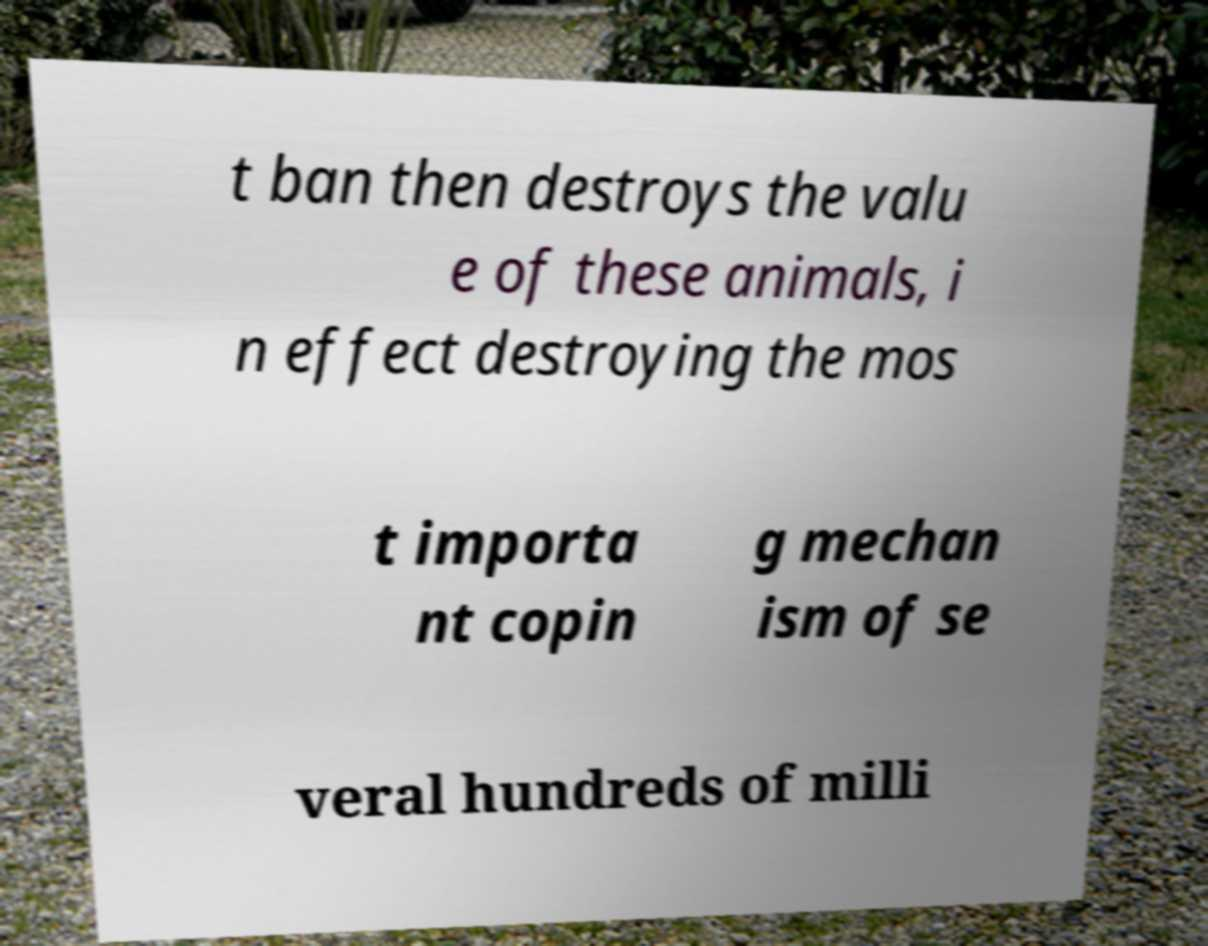I need the written content from this picture converted into text. Can you do that? t ban then destroys the valu e of these animals, i n effect destroying the mos t importa nt copin g mechan ism of se veral hundreds of milli 